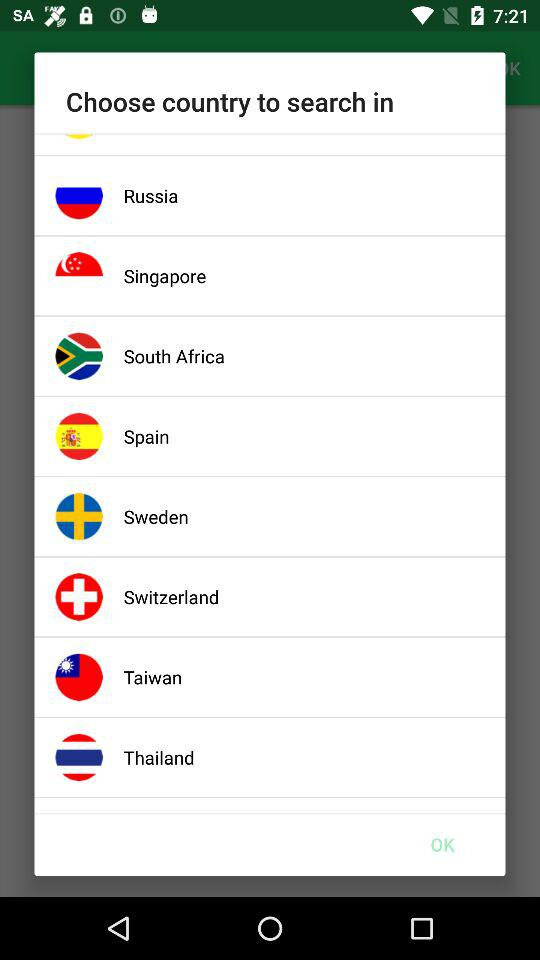What are the different countries? The different countries are Russia, Singapore, South Africa, Spain, Sweden, Switzerland, Taiwan and Thailand. 